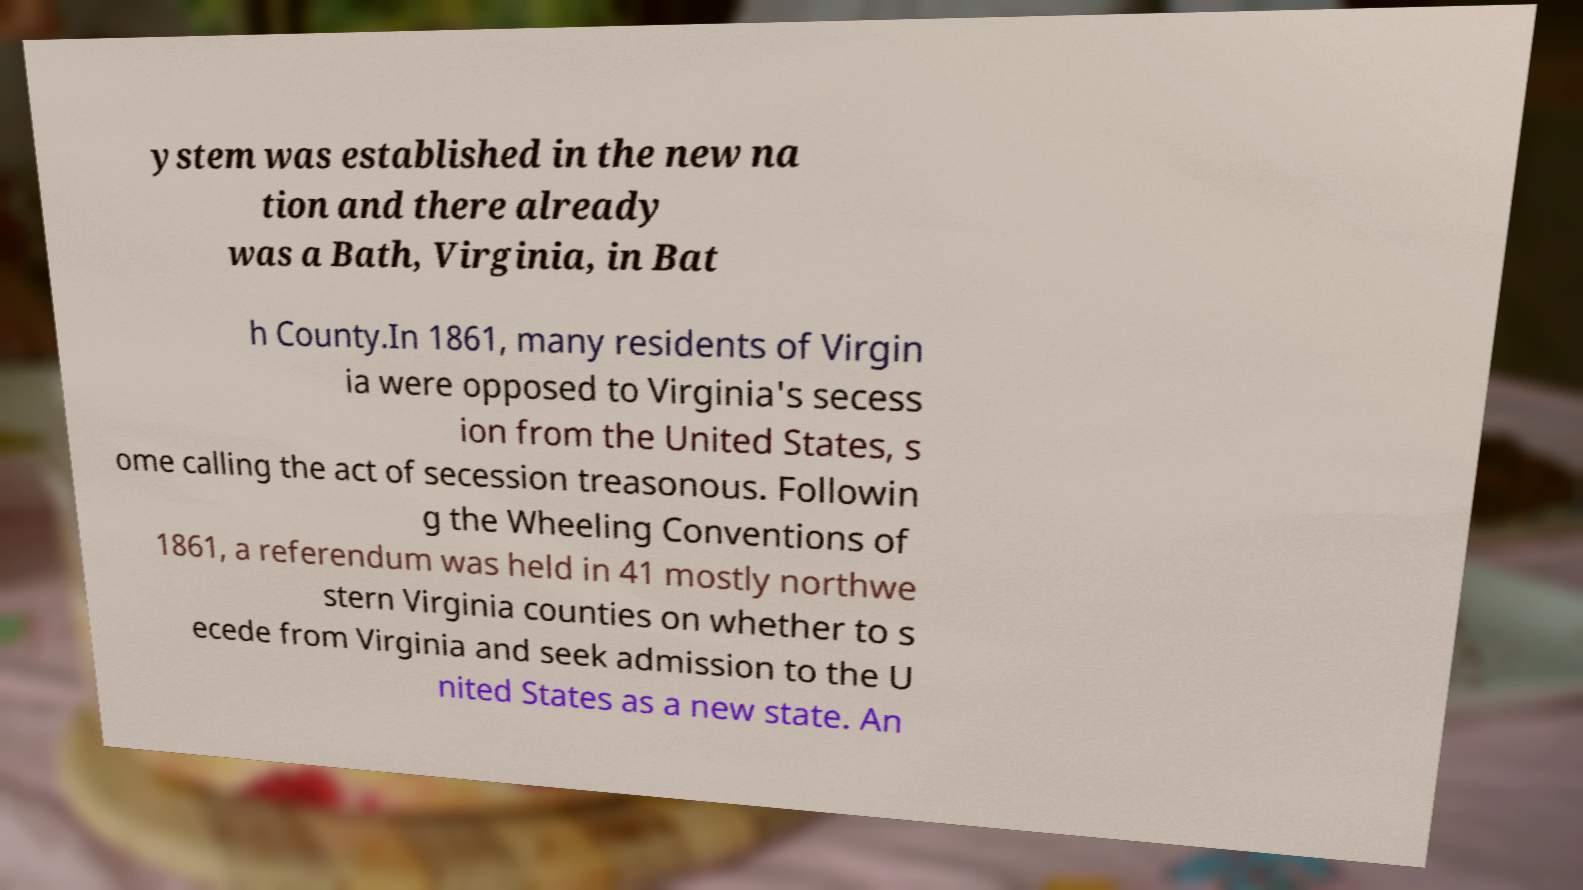Please identify and transcribe the text found in this image. ystem was established in the new na tion and there already was a Bath, Virginia, in Bat h County.In 1861, many residents of Virgin ia were opposed to Virginia's secess ion from the United States, s ome calling the act of secession treasonous. Followin g the Wheeling Conventions of 1861, a referendum was held in 41 mostly northwe stern Virginia counties on whether to s ecede from Virginia and seek admission to the U nited States as a new state. An 